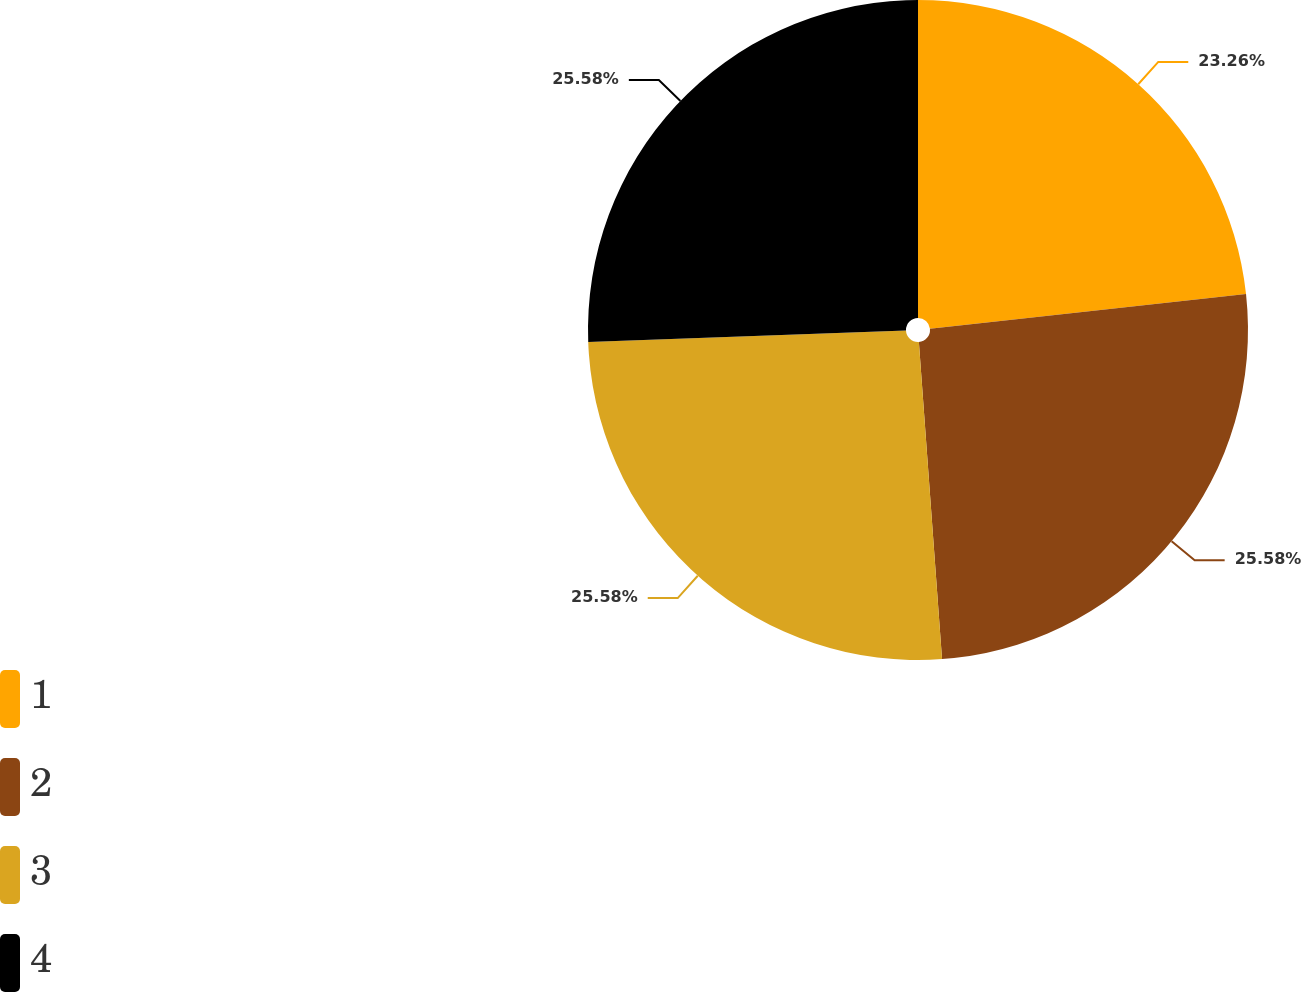Convert chart to OTSL. <chart><loc_0><loc_0><loc_500><loc_500><pie_chart><fcel>1<fcel>2<fcel>3<fcel>4<nl><fcel>23.26%<fcel>25.58%<fcel>25.58%<fcel>25.58%<nl></chart> 